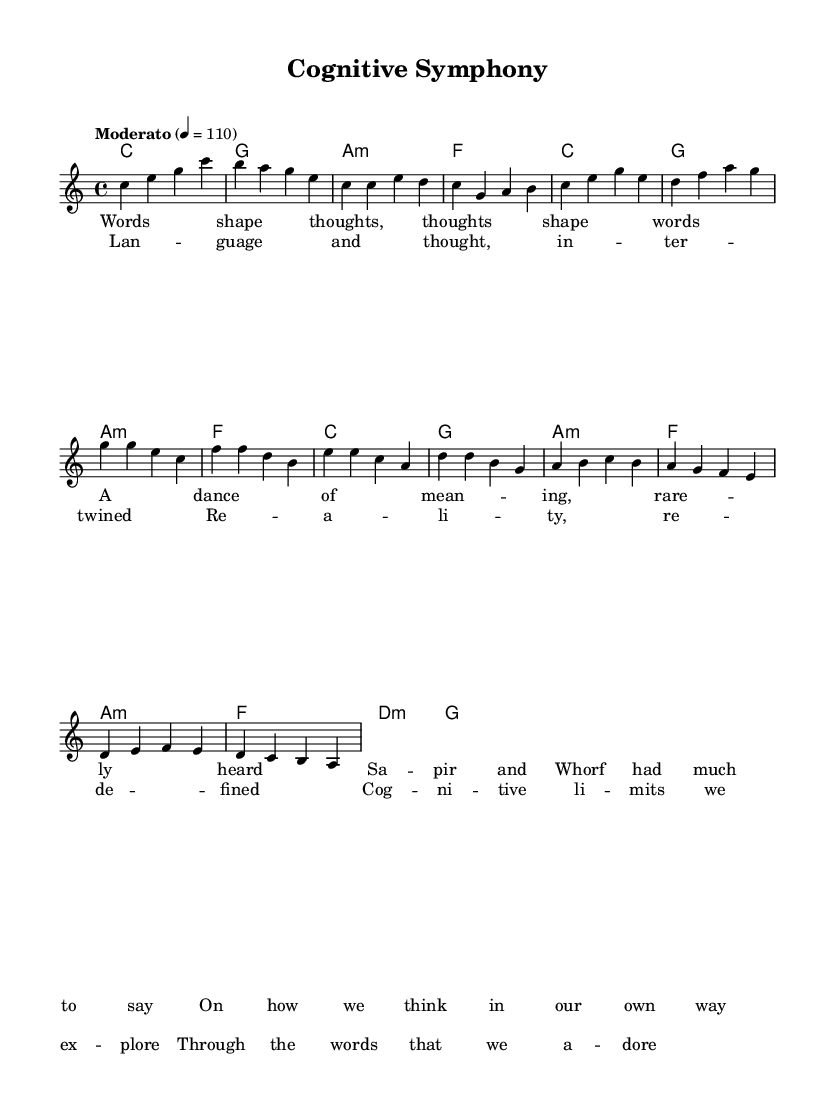What is the key signature of this music? The key signature is indicated at the beginning of the score, where it shows C major, which has no sharps or flats.
Answer: C major What is the time signature of this music? The time signature is found in the initial part of the score, showing a 4 over 4, which means there are four beats in a measure.
Answer: 4/4 What is the tempo marking? The tempo is denoted above the staff, indicating "Moderato" and a specific beat of 110, which refers to the pace of the music.
Answer: Moderato How many measures are in the verse section? By counting the individual measures laid out in the verse lyric section, we find there are four measures present.
Answer: 4 What describes the relationship between lyrics and melody in the chorus? The chorus lyrics present thematic content that reflects the concept of language and thought interconnection, matched by an engaging melody highlighting repetition.
Answer: Intertwined What type of chord is used in the bridge? The chords are labeled, and the bridge primarily uses a minor chord structure (a minor, d minor), suggesting a shift in mood and complexity.
Answer: a minor How is the overall structure of this music categorized? The music is divided into sections: Intro, Verse, Chorus, and Bridge, typical of pop music's song structure that employs repetition and variation.
Answer: Pop song structure 